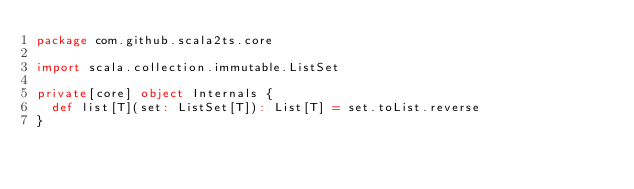<code> <loc_0><loc_0><loc_500><loc_500><_Scala_>package com.github.scala2ts.core

import scala.collection.immutable.ListSet

private[core] object Internals {
  def list[T](set: ListSet[T]): List[T] = set.toList.reverse
}</code> 